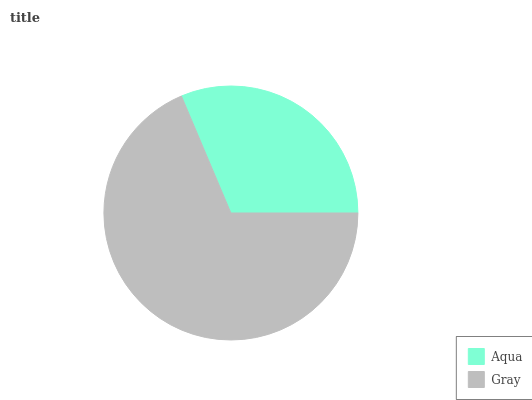Is Aqua the minimum?
Answer yes or no. Yes. Is Gray the maximum?
Answer yes or no. Yes. Is Gray the minimum?
Answer yes or no. No. Is Gray greater than Aqua?
Answer yes or no. Yes. Is Aqua less than Gray?
Answer yes or no. Yes. Is Aqua greater than Gray?
Answer yes or no. No. Is Gray less than Aqua?
Answer yes or no. No. Is Gray the high median?
Answer yes or no. Yes. Is Aqua the low median?
Answer yes or no. Yes. Is Aqua the high median?
Answer yes or no. No. Is Gray the low median?
Answer yes or no. No. 